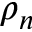<formula> <loc_0><loc_0><loc_500><loc_500>\rho _ { n }</formula> 